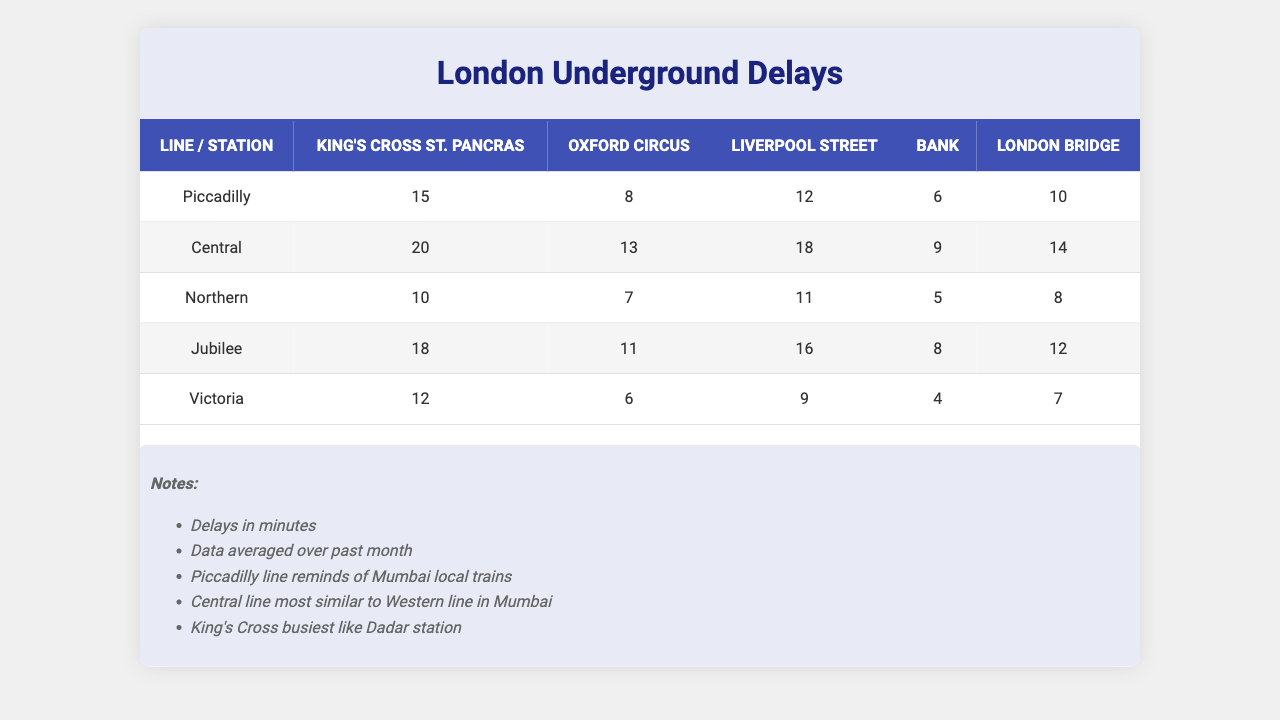What is the highest delay reported for the Victoria line? By looking at the delays for the Victoria line, the values are 12, 6, 9, 4, and 7 minutes. The maximum value is 12 minutes.
Answer: 12 Which station had the least amount of delays during the Morning Rush period? The delays during the Morning Rush for each station are 15 (King's Cross St. Pancras), 20 (Oxford Circus), 10 (Liverpool Street), 18 (Bank), and 12 (London Bridge). The least delay is 10 for Liverpool Street.
Answer: Liverpool Street Is the average delay for the Jubilee line higher than that of the Northern line? The average delay for the Jubilee line is calculated as (18 + 11 + 16 + 8 + 12) / 5 = 13. The average delay for the Northern line is (10 + 7 + 11 + 5 + 8) / 5 = 8. Since 13 > 8, the statement is true.
Answer: Yes What are the total delays recorded for Oxford Circus across all time frames? The delays for Oxford Circus in all time frames are 8, 13, 7, 11, and 6 minutes. Sum these values: 8 + 13 + 7 + 11 + 6 = 45.
Answer: 45 Which line has the highest average delay overall? To find the highest average delay, first calculate the average for each line: Piccadilly: (15 + 8 + 12 + 6 + 10)/5 = 10.2; Central: (20 + 13 + 18 + 9 + 14)/5 = 14.4; Northern: (10 + 7 + 11 + 5 + 8)/5 = 8.2; Jubilee: (18 + 11 + 16 + 8 + 12)/5 = 13; Victoria: (12 + 6 + 9 + 4 + 7)/5 = 7. The highest average is for Central line at 14.4.
Answer: Central How many more minutes of delays does the Jubilee line have compared to the Victoria line in the Evening Rush? The delays for the Jubilee line in the Evening Rush is 16 minutes, while the Victoria line has 9 minutes. The difference is 16 - 9 = 7 minutes.
Answer: 7 Does King's Cross St. Pancras experience delays greater than those of London Bridge during the Late Night period? The Late Night delays for King's Cross St. Pancras are 6 minutes and for London Bridge are 4 minutes. Since 6 > 4, the statement is true.
Answer: Yes What is the total delay for the Central line during the Morning Rush and Evening Rush combined? For the Central line, the delays are 20 minutes (Morning Rush) and 18 minutes (Evening Rush). The total is 20 + 18 = 38 minutes.
Answer: 38 Which station has the maximum delay and what is the time frame? The maximum delay across all stations is 20 minutes at Oxford Circus during the Morning Rush timeframe.
Answer: Oxford Circus, Morning Rush What is the average delay for all lines during the Weekend? To calculate the average for the Weekend, sum the delays for all lines: 10 (Piccadilly) + 14 (Central) + 8 (Northern) + 12 (Jubilee) + 7 (Victoria) = 51. Since there are 5 lines, the average is 51 / 5 = 10.2.
Answer: 10.2 Does the average delay for Liverpool Street exceed the overall average delay for all stations? First, calculate the average for Liverpool Street: (12 + 18 + 11 + 16 + 9) / 5 = 13.2. Now, calculate the overall average: The total delays = 15+20+10+18+12 + 8+13+7+11+6 + 12+14+8+12+7 + 18+11+16+8+12 + 10+6+9+4+7 = 162, average = 162 / 25 = 6.48. Since 13.2 > 6.48, the statement is true.
Answer: Yes 